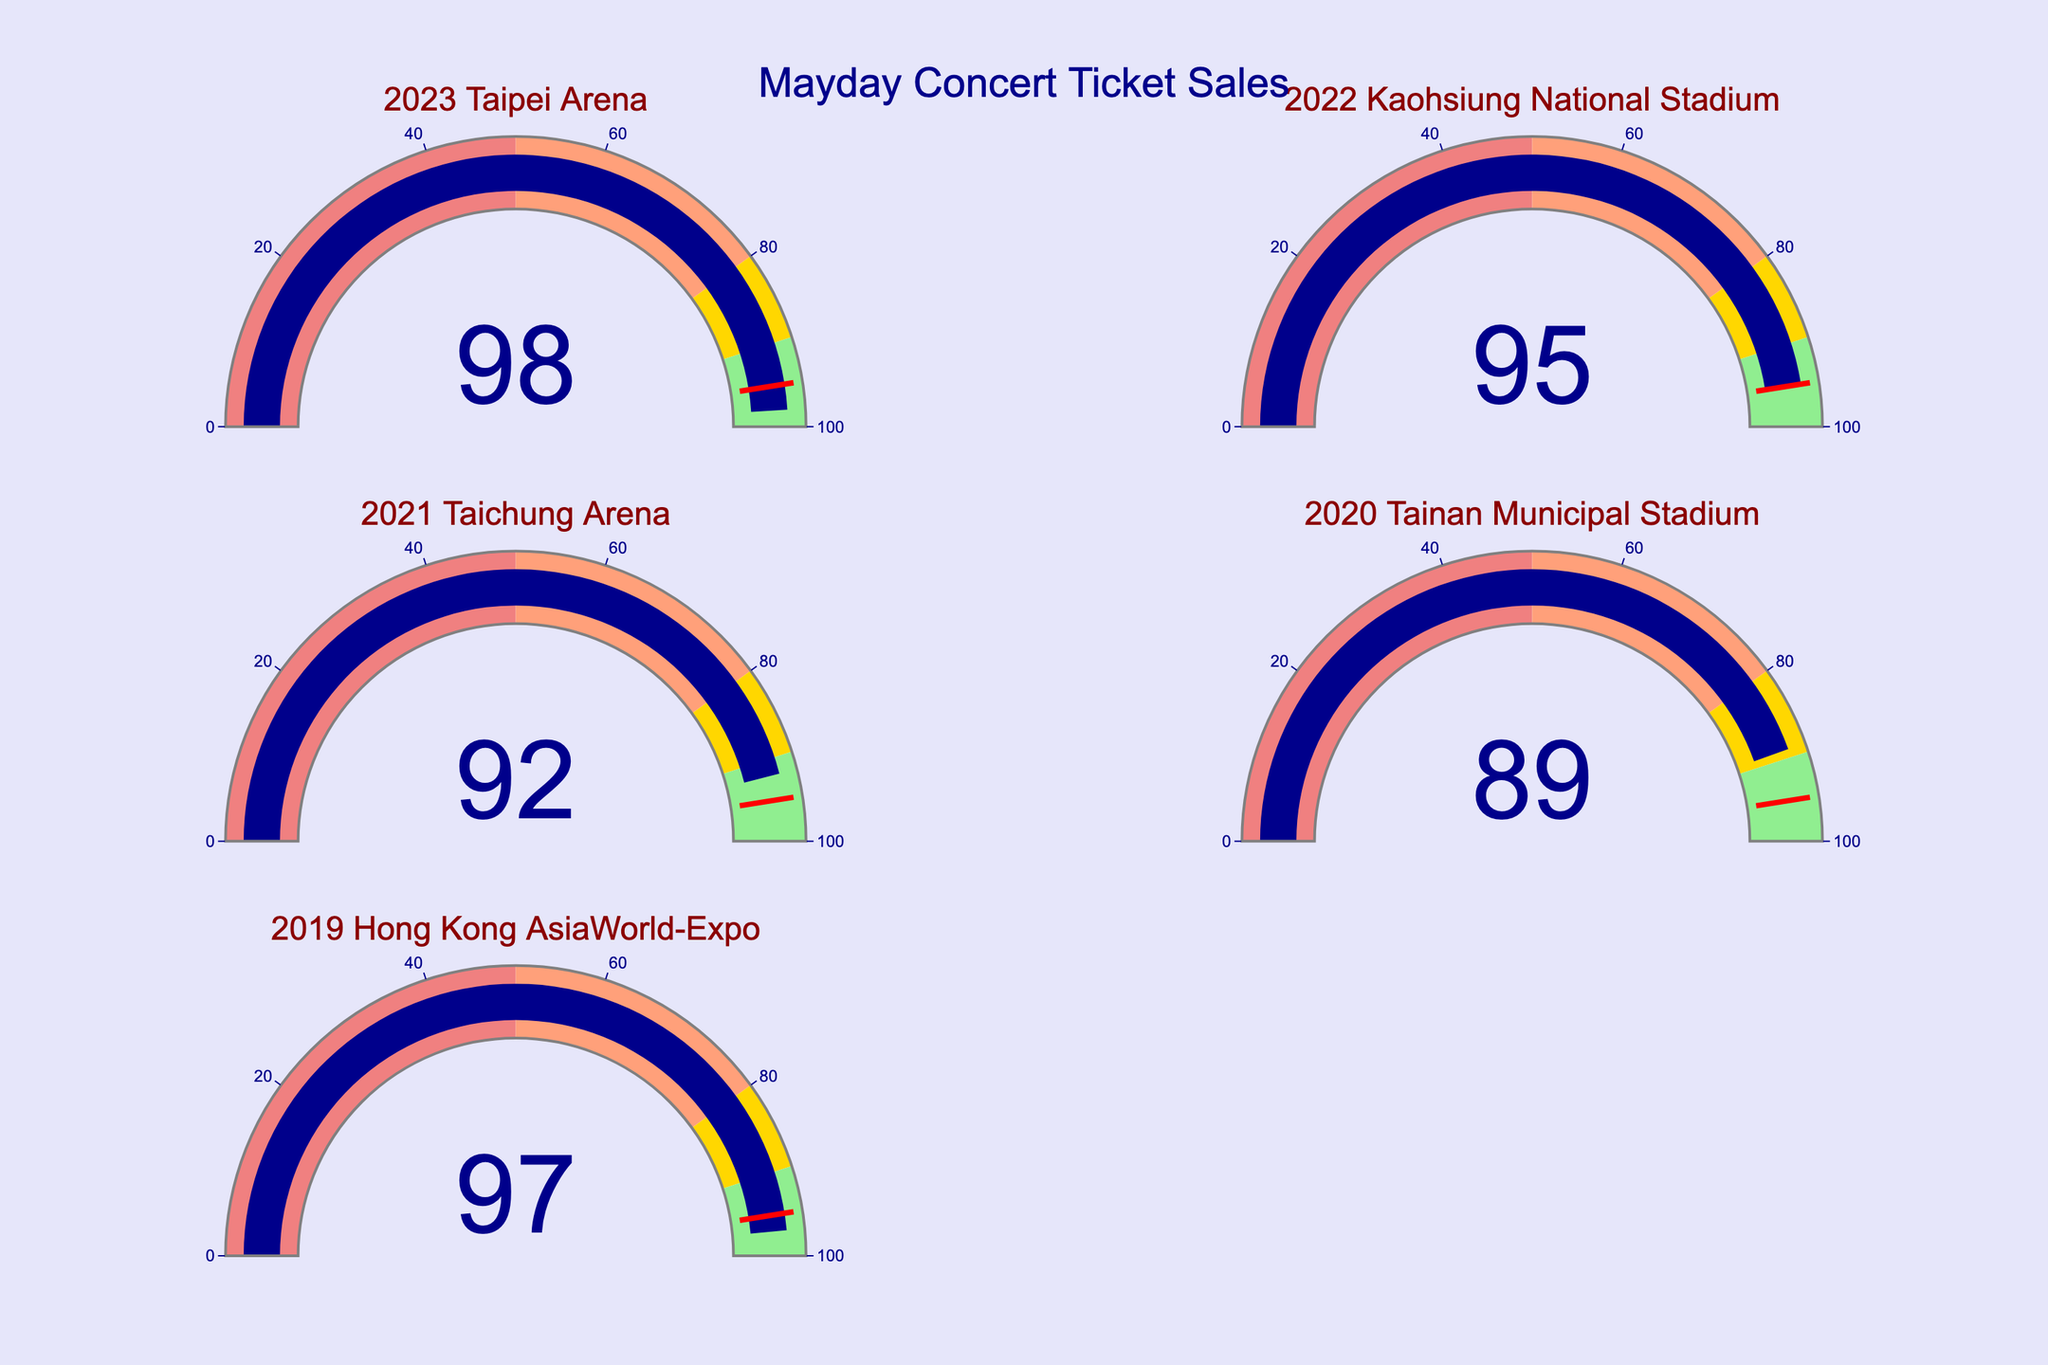What is the title of the figure? The title of a figure is typically displayed at the top. In this case, you can see "Mayday Concert Ticket Sales" prominently centered at the top of the figure.
Answer: Mayday Concert Ticket Sales Which concert had the highest percentage of tickets sold out within the first hour? Look at the gauge charts to identify the concert with the highest gauge value. The "2023 Taipei Arena" concert has the highest value at 98%.
Answer: 2023 Taipei Arena What color represents the range for sold-out percentages between 80 and 90? Examine the different color ranges on the gauge. The range between 80 and 90 is represented by gold color.
Answer: Gold What is the average sold-out percentage for the concerts shown in the figure? Sum the sold-out percentages: 98, 95, 92, 89, 97. The total is 471. Divide this by the number of concerts, which is 5. 471 / 5 = 94.2.
Answer: 94.2 Which concerts had a sold-out percentage above 90%? Identify the concerts with gauges indicating sold-out percentages above 90%. These concerts are: 2023 Taipei Arena (98%), 2022 Kaohsiung National Stadium (95%), 2021 Taichung Arena (92%), and 2019 Hong Kong AsiaWorld-Expo (97%).
Answer: 2023 Taipei Arena, 2022 Kaohsiung National Stadium, 2021 Taichung Arena, 2019 Hong Kong AsiaWorld-Expo How many concerts in the figure had a sold-out percentage below 90%? Check the gauge charts for percentages below 90%. Only the "2020 Tainan Municipal Stadium" concert had a sold-out percentage below 90% at 89%.
Answer: 1 Which concert had a sold-out percentage closest to the threshold value of 95%? Compare the sold-out percentages to 95%. "2022 Kaohsiung National Stadium" had a sold-out percentage exactly at 95%, which matches the threshold value.
Answer: 2022 Kaohsiung National Stadium What is the difference in sold-out percentage between the 2021 and 2020 concerts? Subtract the sold-out percentage of the 2020 Tainan Municipal Stadium (89%) from the 2021 Taichung Arena (92%). 92 - 89 = 3.
Answer: 3 What is the median sold-out percentage of the concerts shown in the figure? List the percentages in ascending order: 89, 92, 95, 97, 98. The middle value in the ordered list (the third value) is 95.
Answer: 95 